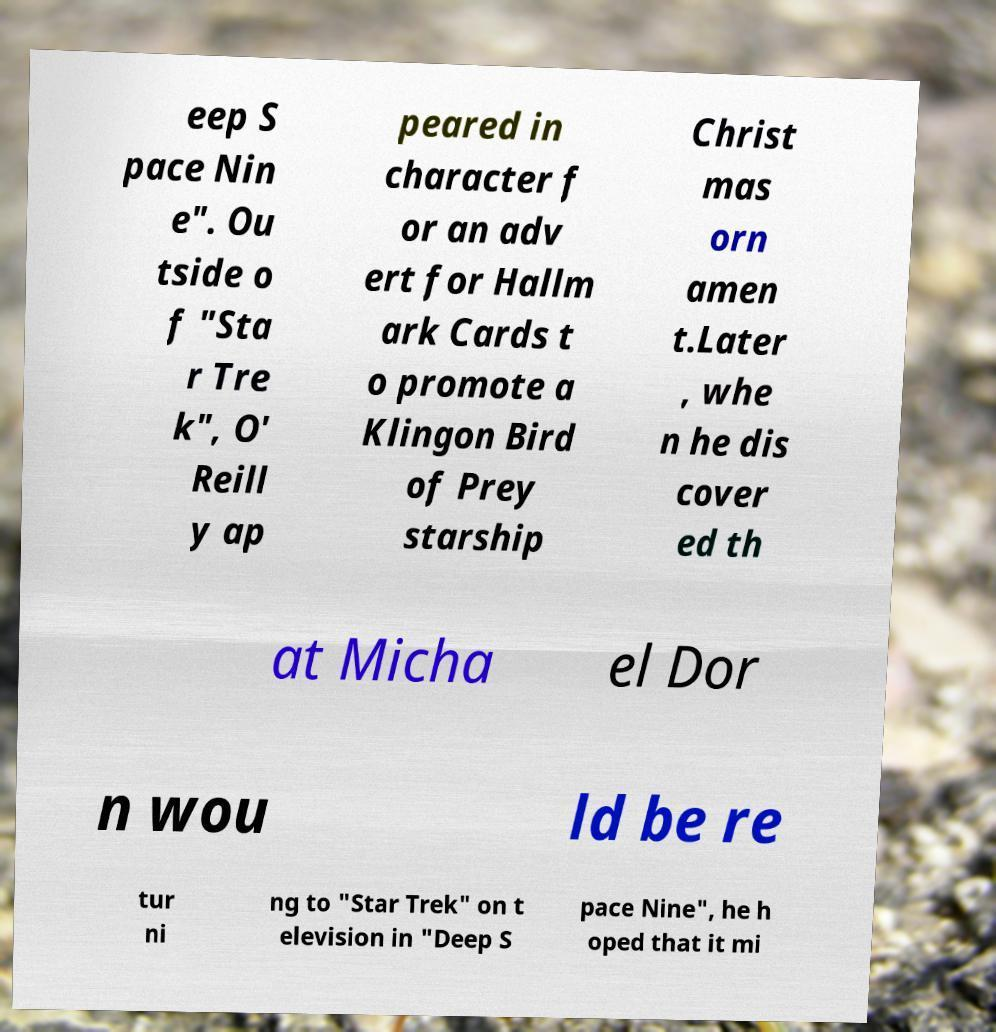Please read and relay the text visible in this image. What does it say? eep S pace Nin e". Ou tside o f "Sta r Tre k", O' Reill y ap peared in character f or an adv ert for Hallm ark Cards t o promote a Klingon Bird of Prey starship Christ mas orn amen t.Later , whe n he dis cover ed th at Micha el Dor n wou ld be re tur ni ng to "Star Trek" on t elevision in "Deep S pace Nine", he h oped that it mi 